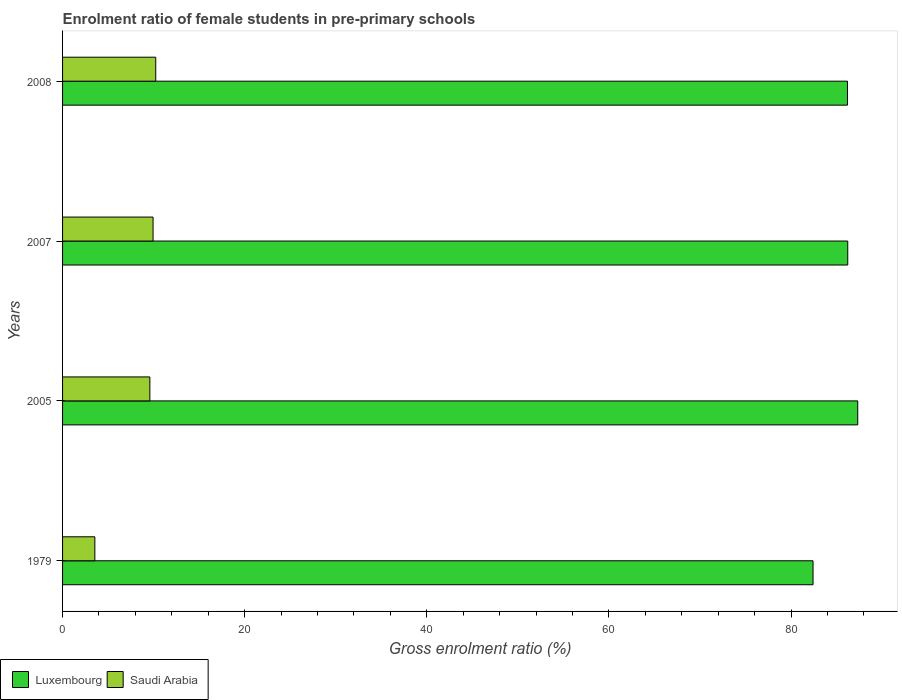How many bars are there on the 2nd tick from the top?
Keep it short and to the point. 2. How many bars are there on the 4th tick from the bottom?
Provide a short and direct response. 2. What is the label of the 4th group of bars from the top?
Keep it short and to the point. 1979. In how many cases, is the number of bars for a given year not equal to the number of legend labels?
Your answer should be very brief. 0. What is the enrolment ratio of female students in pre-primary schools in Saudi Arabia in 2005?
Keep it short and to the point. 9.59. Across all years, what is the maximum enrolment ratio of female students in pre-primary schools in Saudi Arabia?
Provide a succinct answer. 10.23. Across all years, what is the minimum enrolment ratio of female students in pre-primary schools in Luxembourg?
Keep it short and to the point. 82.41. In which year was the enrolment ratio of female students in pre-primary schools in Saudi Arabia minimum?
Your answer should be very brief. 1979. What is the total enrolment ratio of female students in pre-primary schools in Saudi Arabia in the graph?
Keep it short and to the point. 33.31. What is the difference between the enrolment ratio of female students in pre-primary schools in Luxembourg in 1979 and that in 2005?
Your answer should be very brief. -4.91. What is the difference between the enrolment ratio of female students in pre-primary schools in Luxembourg in 2005 and the enrolment ratio of female students in pre-primary schools in Saudi Arabia in 2008?
Provide a short and direct response. 77.09. What is the average enrolment ratio of female students in pre-primary schools in Luxembourg per year?
Give a very brief answer. 85.54. In the year 2007, what is the difference between the enrolment ratio of female students in pre-primary schools in Saudi Arabia and enrolment ratio of female students in pre-primary schools in Luxembourg?
Make the answer very short. -76.29. In how many years, is the enrolment ratio of female students in pre-primary schools in Luxembourg greater than 80 %?
Keep it short and to the point. 4. What is the ratio of the enrolment ratio of female students in pre-primary schools in Saudi Arabia in 1979 to that in 2005?
Provide a short and direct response. 0.37. Is the enrolment ratio of female students in pre-primary schools in Saudi Arabia in 2005 less than that in 2008?
Your answer should be very brief. Yes. Is the difference between the enrolment ratio of female students in pre-primary schools in Saudi Arabia in 1979 and 2005 greater than the difference between the enrolment ratio of female students in pre-primary schools in Luxembourg in 1979 and 2005?
Ensure brevity in your answer.  No. What is the difference between the highest and the second highest enrolment ratio of female students in pre-primary schools in Luxembourg?
Give a very brief answer. 1.1. What is the difference between the highest and the lowest enrolment ratio of female students in pre-primary schools in Luxembourg?
Your answer should be compact. 4.91. What does the 1st bar from the top in 2007 represents?
Provide a short and direct response. Saudi Arabia. What does the 2nd bar from the bottom in 2005 represents?
Offer a very short reply. Saudi Arabia. What is the difference between two consecutive major ticks on the X-axis?
Give a very brief answer. 20. Does the graph contain any zero values?
Offer a terse response. No. Does the graph contain grids?
Make the answer very short. No. How are the legend labels stacked?
Your answer should be compact. Horizontal. What is the title of the graph?
Give a very brief answer. Enrolment ratio of female students in pre-primary schools. What is the Gross enrolment ratio (%) in Luxembourg in 1979?
Offer a terse response. 82.41. What is the Gross enrolment ratio (%) of Saudi Arabia in 1979?
Your response must be concise. 3.55. What is the Gross enrolment ratio (%) of Luxembourg in 2005?
Offer a very short reply. 87.32. What is the Gross enrolment ratio (%) in Saudi Arabia in 2005?
Provide a succinct answer. 9.59. What is the Gross enrolment ratio (%) of Luxembourg in 2007?
Offer a terse response. 86.22. What is the Gross enrolment ratio (%) of Saudi Arabia in 2007?
Provide a short and direct response. 9.94. What is the Gross enrolment ratio (%) in Luxembourg in 2008?
Offer a very short reply. 86.2. What is the Gross enrolment ratio (%) in Saudi Arabia in 2008?
Offer a terse response. 10.23. Across all years, what is the maximum Gross enrolment ratio (%) of Luxembourg?
Provide a short and direct response. 87.32. Across all years, what is the maximum Gross enrolment ratio (%) of Saudi Arabia?
Offer a terse response. 10.23. Across all years, what is the minimum Gross enrolment ratio (%) in Luxembourg?
Your answer should be very brief. 82.41. Across all years, what is the minimum Gross enrolment ratio (%) of Saudi Arabia?
Give a very brief answer. 3.55. What is the total Gross enrolment ratio (%) of Luxembourg in the graph?
Your answer should be very brief. 342.15. What is the total Gross enrolment ratio (%) of Saudi Arabia in the graph?
Offer a very short reply. 33.31. What is the difference between the Gross enrolment ratio (%) of Luxembourg in 1979 and that in 2005?
Make the answer very short. -4.91. What is the difference between the Gross enrolment ratio (%) of Saudi Arabia in 1979 and that in 2005?
Ensure brevity in your answer.  -6.04. What is the difference between the Gross enrolment ratio (%) in Luxembourg in 1979 and that in 2007?
Your response must be concise. -3.81. What is the difference between the Gross enrolment ratio (%) of Saudi Arabia in 1979 and that in 2007?
Keep it short and to the point. -6.39. What is the difference between the Gross enrolment ratio (%) in Luxembourg in 1979 and that in 2008?
Give a very brief answer. -3.78. What is the difference between the Gross enrolment ratio (%) in Saudi Arabia in 1979 and that in 2008?
Your answer should be compact. -6.69. What is the difference between the Gross enrolment ratio (%) of Luxembourg in 2005 and that in 2007?
Your response must be concise. 1.1. What is the difference between the Gross enrolment ratio (%) of Saudi Arabia in 2005 and that in 2007?
Keep it short and to the point. -0.35. What is the difference between the Gross enrolment ratio (%) in Luxembourg in 2005 and that in 2008?
Provide a succinct answer. 1.13. What is the difference between the Gross enrolment ratio (%) of Saudi Arabia in 2005 and that in 2008?
Provide a succinct answer. -0.65. What is the difference between the Gross enrolment ratio (%) in Luxembourg in 2007 and that in 2008?
Make the answer very short. 0.03. What is the difference between the Gross enrolment ratio (%) of Saudi Arabia in 2007 and that in 2008?
Offer a terse response. -0.29. What is the difference between the Gross enrolment ratio (%) of Luxembourg in 1979 and the Gross enrolment ratio (%) of Saudi Arabia in 2005?
Keep it short and to the point. 72.83. What is the difference between the Gross enrolment ratio (%) of Luxembourg in 1979 and the Gross enrolment ratio (%) of Saudi Arabia in 2007?
Ensure brevity in your answer.  72.47. What is the difference between the Gross enrolment ratio (%) of Luxembourg in 1979 and the Gross enrolment ratio (%) of Saudi Arabia in 2008?
Offer a very short reply. 72.18. What is the difference between the Gross enrolment ratio (%) of Luxembourg in 2005 and the Gross enrolment ratio (%) of Saudi Arabia in 2007?
Provide a succinct answer. 77.38. What is the difference between the Gross enrolment ratio (%) of Luxembourg in 2005 and the Gross enrolment ratio (%) of Saudi Arabia in 2008?
Give a very brief answer. 77.09. What is the difference between the Gross enrolment ratio (%) in Luxembourg in 2007 and the Gross enrolment ratio (%) in Saudi Arabia in 2008?
Keep it short and to the point. 75.99. What is the average Gross enrolment ratio (%) in Luxembourg per year?
Your answer should be compact. 85.54. What is the average Gross enrolment ratio (%) in Saudi Arabia per year?
Ensure brevity in your answer.  8.33. In the year 1979, what is the difference between the Gross enrolment ratio (%) in Luxembourg and Gross enrolment ratio (%) in Saudi Arabia?
Give a very brief answer. 78.87. In the year 2005, what is the difference between the Gross enrolment ratio (%) in Luxembourg and Gross enrolment ratio (%) in Saudi Arabia?
Offer a terse response. 77.73. In the year 2007, what is the difference between the Gross enrolment ratio (%) in Luxembourg and Gross enrolment ratio (%) in Saudi Arabia?
Make the answer very short. 76.29. In the year 2008, what is the difference between the Gross enrolment ratio (%) in Luxembourg and Gross enrolment ratio (%) in Saudi Arabia?
Offer a very short reply. 75.96. What is the ratio of the Gross enrolment ratio (%) of Luxembourg in 1979 to that in 2005?
Provide a short and direct response. 0.94. What is the ratio of the Gross enrolment ratio (%) in Saudi Arabia in 1979 to that in 2005?
Your answer should be very brief. 0.37. What is the ratio of the Gross enrolment ratio (%) of Luxembourg in 1979 to that in 2007?
Offer a terse response. 0.96. What is the ratio of the Gross enrolment ratio (%) in Saudi Arabia in 1979 to that in 2007?
Offer a very short reply. 0.36. What is the ratio of the Gross enrolment ratio (%) of Luxembourg in 1979 to that in 2008?
Give a very brief answer. 0.96. What is the ratio of the Gross enrolment ratio (%) in Saudi Arabia in 1979 to that in 2008?
Give a very brief answer. 0.35. What is the ratio of the Gross enrolment ratio (%) of Luxembourg in 2005 to that in 2007?
Offer a terse response. 1.01. What is the ratio of the Gross enrolment ratio (%) of Saudi Arabia in 2005 to that in 2007?
Your answer should be compact. 0.96. What is the ratio of the Gross enrolment ratio (%) in Luxembourg in 2005 to that in 2008?
Provide a short and direct response. 1.01. What is the ratio of the Gross enrolment ratio (%) of Saudi Arabia in 2005 to that in 2008?
Provide a short and direct response. 0.94. What is the ratio of the Gross enrolment ratio (%) in Luxembourg in 2007 to that in 2008?
Keep it short and to the point. 1. What is the ratio of the Gross enrolment ratio (%) of Saudi Arabia in 2007 to that in 2008?
Give a very brief answer. 0.97. What is the difference between the highest and the second highest Gross enrolment ratio (%) of Luxembourg?
Keep it short and to the point. 1.1. What is the difference between the highest and the second highest Gross enrolment ratio (%) in Saudi Arabia?
Provide a short and direct response. 0.29. What is the difference between the highest and the lowest Gross enrolment ratio (%) of Luxembourg?
Ensure brevity in your answer.  4.91. What is the difference between the highest and the lowest Gross enrolment ratio (%) in Saudi Arabia?
Your answer should be compact. 6.69. 